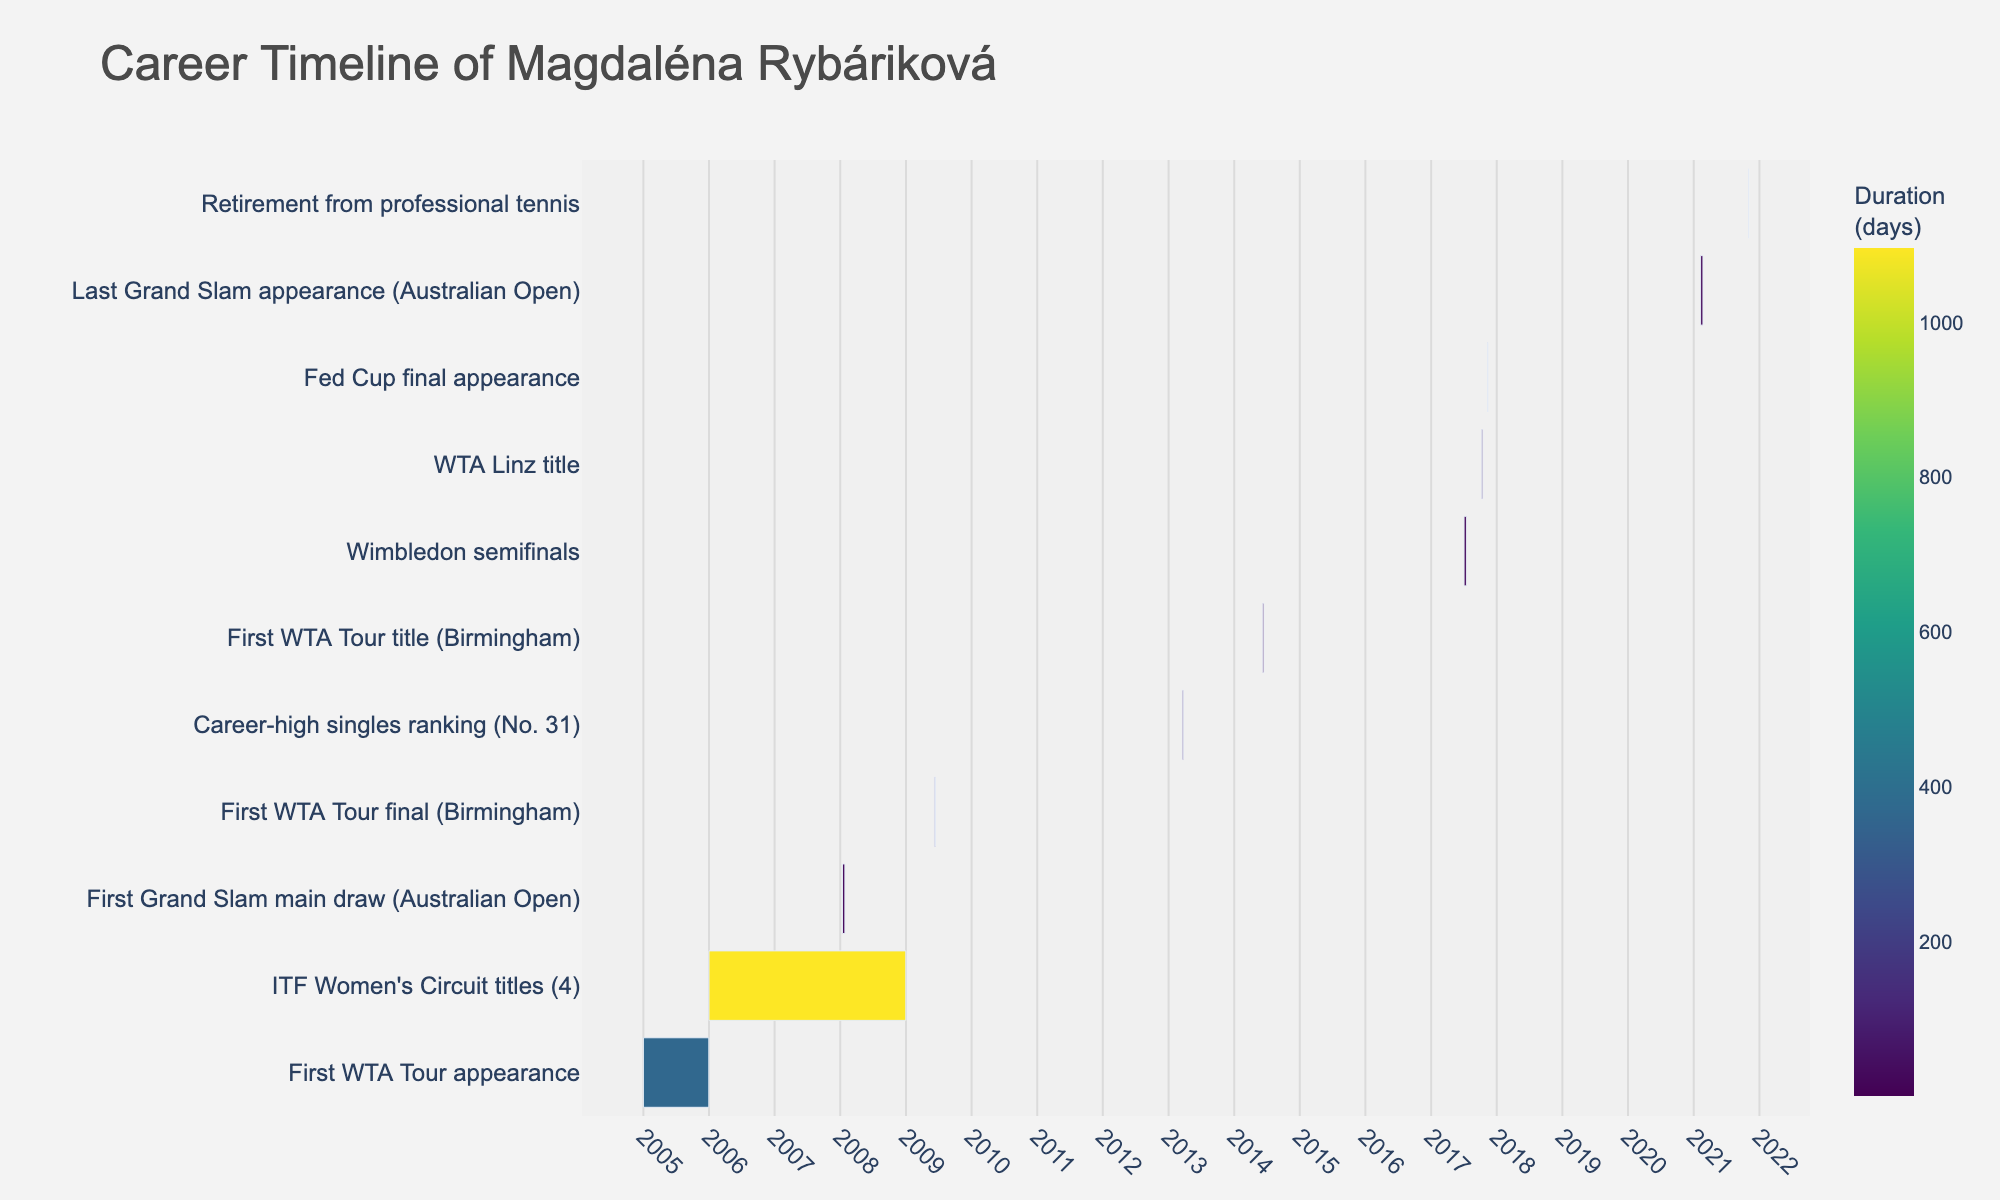What is the title of the chart? The title is usually located at the top of the chart and provides an overview of what the chart represents. In this case, it's about the career timeline of a tennis player.
Answer: Career Timeline of Magdaléna Rybáriková Which event lasted the shortest duration? To determine the shortest duration, examine the lengths of the bars in the chart. The shortest bar represents the task with the shortest duration.
Answer: Retirement from professional tennis (1 day) When did Magdaléna Rybáriková first appear in a Grand Slam main draw? Look for the event labeled "First Grand Slam main draw (Australian Open)" and note the start date beside it.
Answer: January 14, 2008 What was the duration of Magdaléna Rybáriková's Wimbledon semifinal appearance? Locate the Wimbledon semifinals bar and measure its length, which corresponds to the duration. Identify the start and end dates and compute the difference.
Answer: 14 days How many years span the events from "First WTA Tour appearance" to "Retirement from professional tennis"? Check the start date of the first event and the end date of the last event, then calculate the difference in years.
Answer: 16 years Which event had the longest duration? The event with the longest duration can be found by examining the longest bar in the chart.
Answer: ITF Women's Circuit titles (1096 days) How long after her first WTA Tour appearance did Magdaléna Rybáriková achieve her career-high singles ranking (No. 31)? Find the end date of the "First WTA Tour appearance" and the start date of "Career-high singles ranking (No. 31)" and calculate the difference in years or days.
Answer: Approximately 8 years and 2 months What is the color scale used in the chart? The chart uses a sequential color scale to represent duration. Identify the specific color gradient used.
Answer: Viridis Compare the duration of the "First WTA Tour title (Birmingham)" with the "WTA Linz title." Which one lasted longer? Measure the bars representing these two events and compare their lengths to see which one lasted longer.
Answer: They lasted the same duration (7 days each) How many major events took place in 2017, and what were they? Identify events that occurred in 2017 by looking at the start and end dates, then count and list them.
Answer: Three events: Wimbledon semifinals, WTA Linz title, and Fed Cup final appearance 